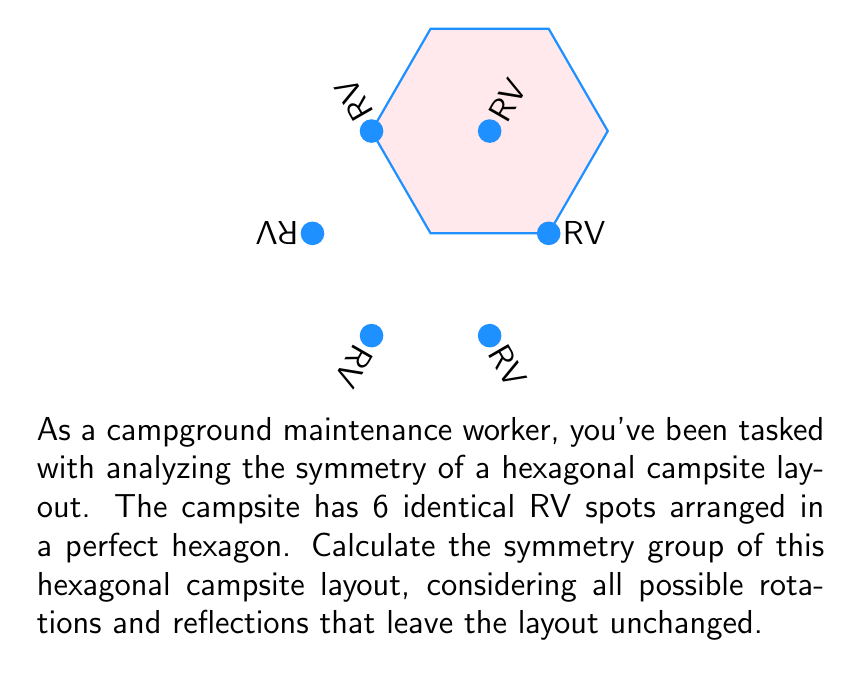Teach me how to tackle this problem. To determine the symmetry group of the hexagonal campsite layout, we need to consider all transformations that leave the layout unchanged. For a regular hexagon, these include rotations and reflections.

1. Rotational symmetries:
   - Identity (0° rotation)
   - Rotations by 60°, 120°, 180°, 240°, and 300°
   Total: 6 rotational symmetries

2. Reflection symmetries:
   - 6 lines of reflection (3 through opposite vertices and 3 through midpoints of opposite sides)
   Total: 6 reflection symmetries

The total number of symmetries is 12 (6 rotations + 6 reflections).

These symmetries form a group under composition. This group is isomorphic to the dihedral group $D_6$, which is the symmetry group of a regular hexagon.

The group $D_6$ has the following properties:
- Order: $|D_6| = 12$
- Generators: $r$ (rotation by 60°) and $s$ (reflection)
- Presentation: $D_6 = \langle r, s \mid r^6 = s^2 = 1, srs = r^{-1} \rangle$

The elements of $D_6$ can be written as:
$$D_6 = \{1, r, r^2, r^3, r^4, r^5, s, sr, sr^2, sr^3, sr^4, sr^5\}$$

where $1$ is the identity, $r^i$ represents rotations, and $sr^i$ represents reflections.
Answer: $D_6$ 